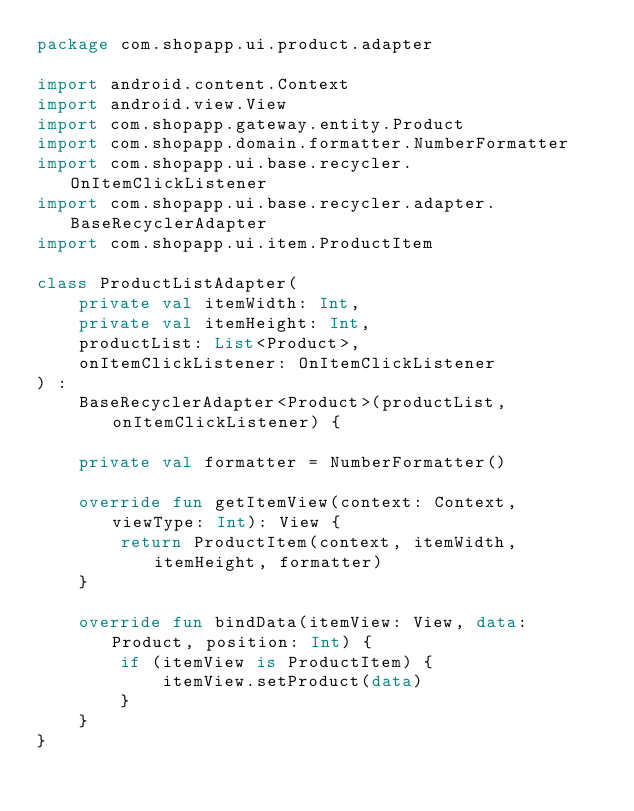Convert code to text. <code><loc_0><loc_0><loc_500><loc_500><_Kotlin_>package com.shopapp.ui.product.adapter

import android.content.Context
import android.view.View
import com.shopapp.gateway.entity.Product
import com.shopapp.domain.formatter.NumberFormatter
import com.shopapp.ui.base.recycler.OnItemClickListener
import com.shopapp.ui.base.recycler.adapter.BaseRecyclerAdapter
import com.shopapp.ui.item.ProductItem

class ProductListAdapter(
    private val itemWidth: Int,
    private val itemHeight: Int,
    productList: List<Product>,
    onItemClickListener: OnItemClickListener
) :
    BaseRecyclerAdapter<Product>(productList, onItemClickListener) {

    private val formatter = NumberFormatter()

    override fun getItemView(context: Context, viewType: Int): View {
        return ProductItem(context, itemWidth, itemHeight, formatter)
    }

    override fun bindData(itemView: View, data: Product, position: Int) {
        if (itemView is ProductItem) {
            itemView.setProduct(data)
        }
    }
}</code> 